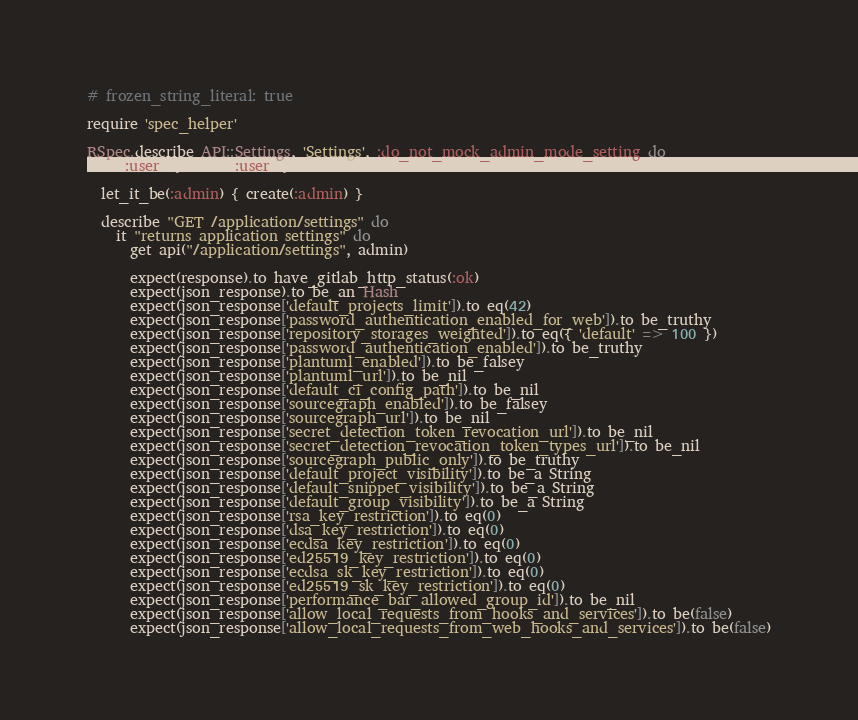<code> <loc_0><loc_0><loc_500><loc_500><_Ruby_># frozen_string_literal: true

require 'spec_helper'

RSpec.describe API::Settings, 'Settings', :do_not_mock_admin_mode_setting do
  let(:user) { create(:user) }

  let_it_be(:admin) { create(:admin) }

  describe "GET /application/settings" do
    it "returns application settings" do
      get api("/application/settings", admin)

      expect(response).to have_gitlab_http_status(:ok)
      expect(json_response).to be_an Hash
      expect(json_response['default_projects_limit']).to eq(42)
      expect(json_response['password_authentication_enabled_for_web']).to be_truthy
      expect(json_response['repository_storages_weighted']).to eq({ 'default' => 100 })
      expect(json_response['password_authentication_enabled']).to be_truthy
      expect(json_response['plantuml_enabled']).to be_falsey
      expect(json_response['plantuml_url']).to be_nil
      expect(json_response['default_ci_config_path']).to be_nil
      expect(json_response['sourcegraph_enabled']).to be_falsey
      expect(json_response['sourcegraph_url']).to be_nil
      expect(json_response['secret_detection_token_revocation_url']).to be_nil
      expect(json_response['secret_detection_revocation_token_types_url']).to be_nil
      expect(json_response['sourcegraph_public_only']).to be_truthy
      expect(json_response['default_project_visibility']).to be_a String
      expect(json_response['default_snippet_visibility']).to be_a String
      expect(json_response['default_group_visibility']).to be_a String
      expect(json_response['rsa_key_restriction']).to eq(0)
      expect(json_response['dsa_key_restriction']).to eq(0)
      expect(json_response['ecdsa_key_restriction']).to eq(0)
      expect(json_response['ed25519_key_restriction']).to eq(0)
      expect(json_response['ecdsa_sk_key_restriction']).to eq(0)
      expect(json_response['ed25519_sk_key_restriction']).to eq(0)
      expect(json_response['performance_bar_allowed_group_id']).to be_nil
      expect(json_response['allow_local_requests_from_hooks_and_services']).to be(false)
      expect(json_response['allow_local_requests_from_web_hooks_and_services']).to be(false)</code> 